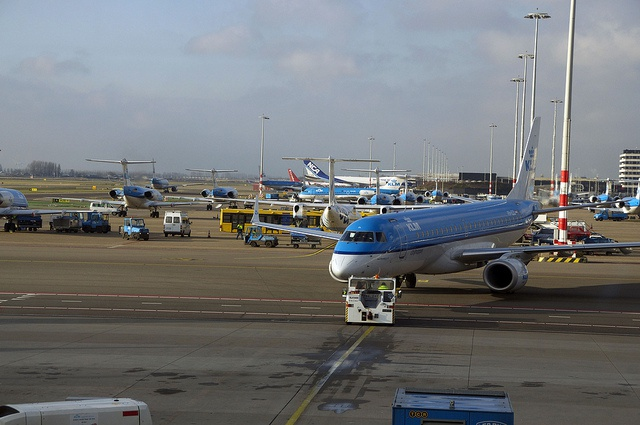Describe the objects in this image and their specific colors. I can see airplane in darkgray, gray, black, and darkblue tones, airplane in darkgray, gray, and lightgray tones, truck in darkgray, black, gray, and darkgreen tones, airplane in darkgray, gray, lightgray, and black tones, and bus in darkgray, black, and olive tones in this image. 